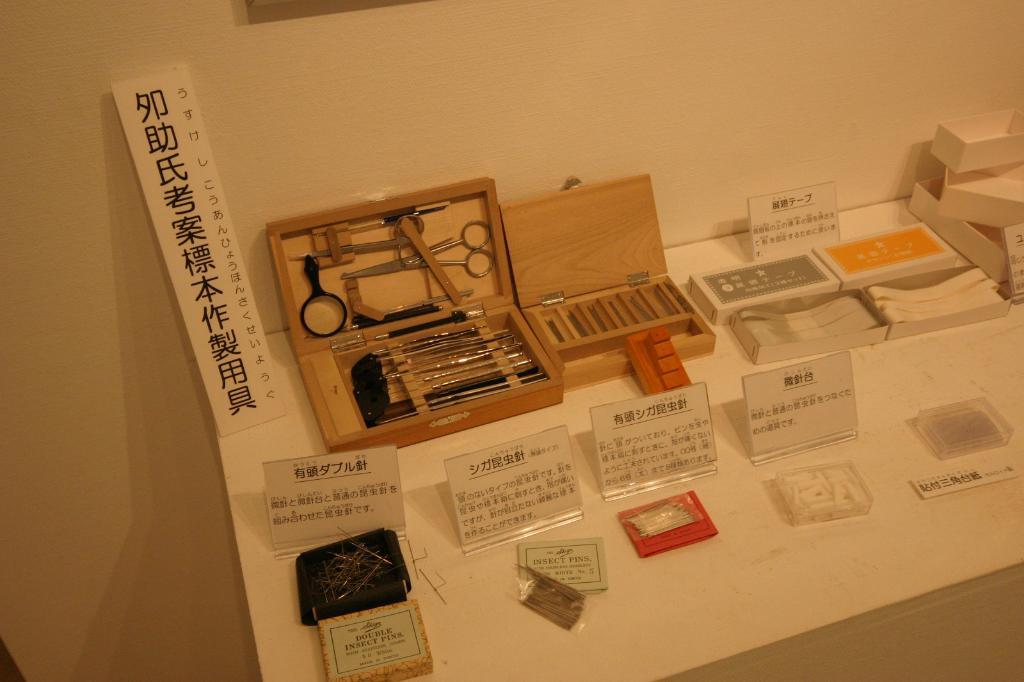<image>
Summarize the visual content of the image. some Japanese writing is on the white paper 